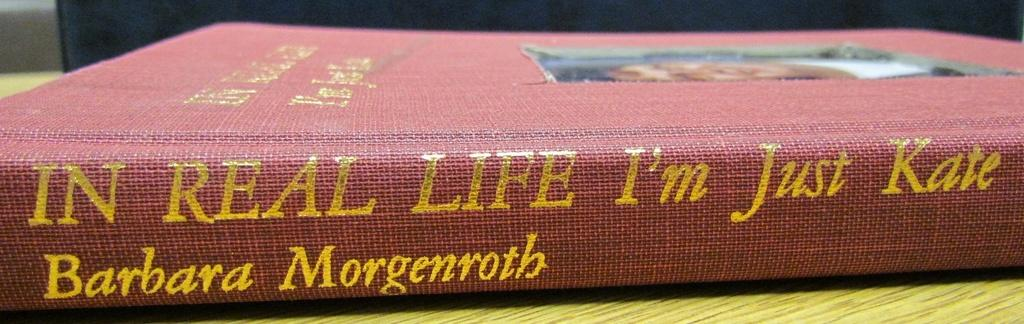Provide a one-sentence caption for the provided image. Barbara Morgenroth wrote a story titled In Real Life I'm Just Kate. 